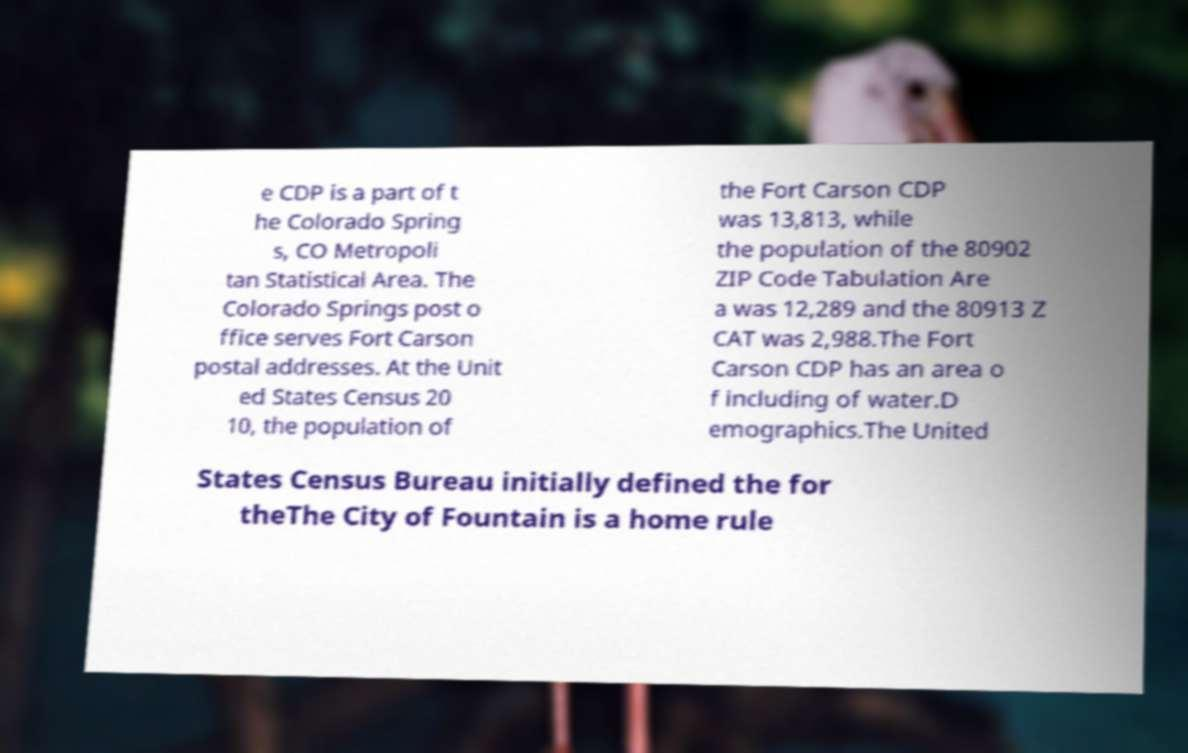Please identify and transcribe the text found in this image. e CDP is a part of t he Colorado Spring s, CO Metropoli tan Statistical Area. The Colorado Springs post o ffice serves Fort Carson postal addresses. At the Unit ed States Census 20 10, the population of the Fort Carson CDP was 13,813, while the population of the 80902 ZIP Code Tabulation Are a was 12,289 and the 80913 Z CAT was 2,988.The Fort Carson CDP has an area o f including of water.D emographics.The United States Census Bureau initially defined the for theThe City of Fountain is a home rule 